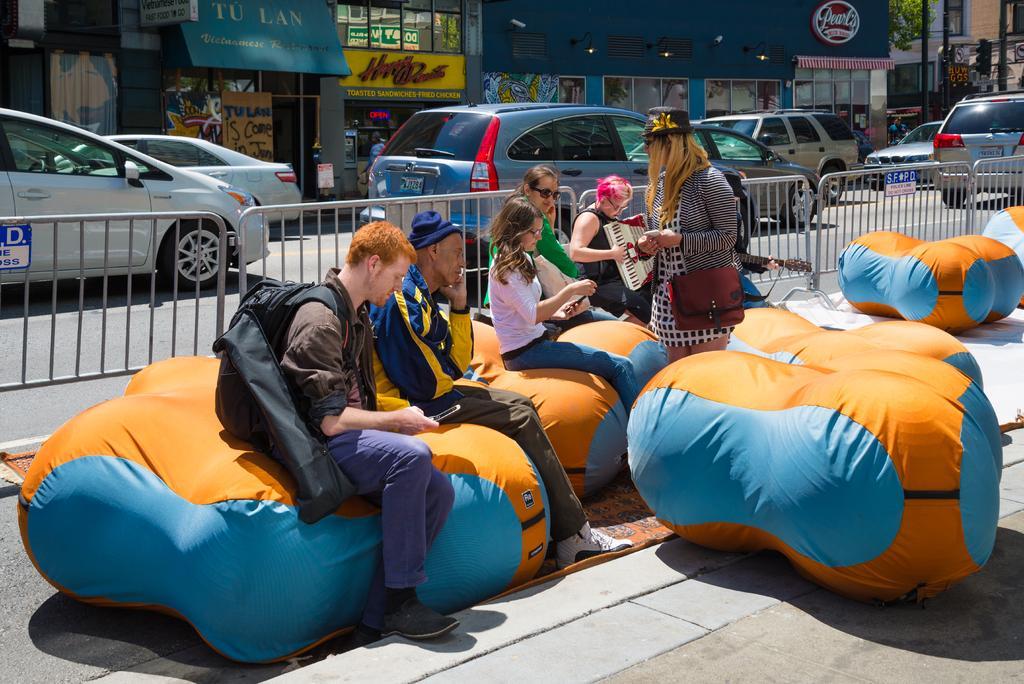Could you give a brief overview of what you see in this image? In the image there are inflatables and few people are sitting on inflatables, beside them a woman is standing, there is a metal fencing behind them and behind the fencing there is a road and on the road there are lot of vehicles, in the background there are many stores. 